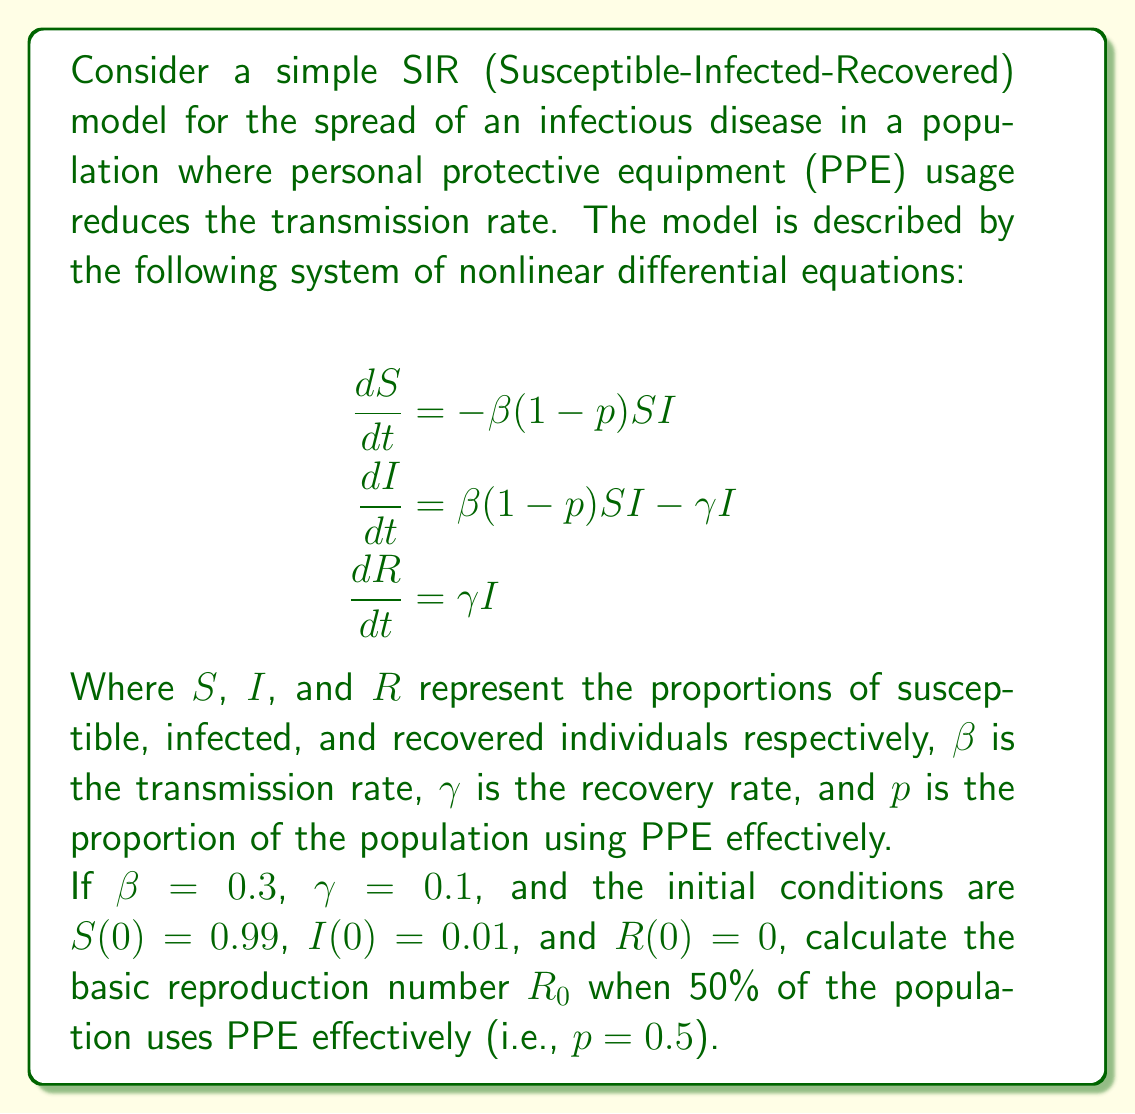Teach me how to tackle this problem. To solve this problem, we'll follow these steps:

1) The basic reproduction number $R_0$ in an SIR model is typically given by the ratio of the transmission rate to the recovery rate:

   $$R_0 = \frac{\beta}{\gamma}$$

2) However, in this case, we need to account for the effect of PPE usage. The effective transmission rate is reduced by a factor of $(1-p)$, where $p$ is the proportion of the population using PPE effectively.

3) Therefore, the adjusted formula for $R_0$ is:

   $$R_0 = \frac{\beta(1-p)}{\gamma}$$

4) We're given the following values:
   $\beta = 0.3$
   $\gamma = 0.1$
   $p = 0.5$

5) Let's substitute these values into our adjusted $R_0$ formula:

   $$R_0 = \frac{0.3(1-0.5)}{0.1}$$

6) Simplify:
   $$R_0 = \frac{0.3 \times 0.5}{0.1} = \frac{0.15}{0.1}$$

7) Calculate the final result:
   $$R_0 = 1.5$$

This value of $R_0$ indicates that, on average, each infected individual will infect 1.5 others in a fully susceptible population, even with 50% PPE usage.
Answer: $R_0 = 1.5$ 